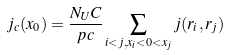Convert formula to latex. <formula><loc_0><loc_0><loc_500><loc_500>j _ { c } ( x _ { 0 } ) = \frac { N _ { U } C } { p c } \sum _ { i < j , x _ { i } < 0 < x _ { j } } j ( r _ { i } , r _ { j } )</formula> 